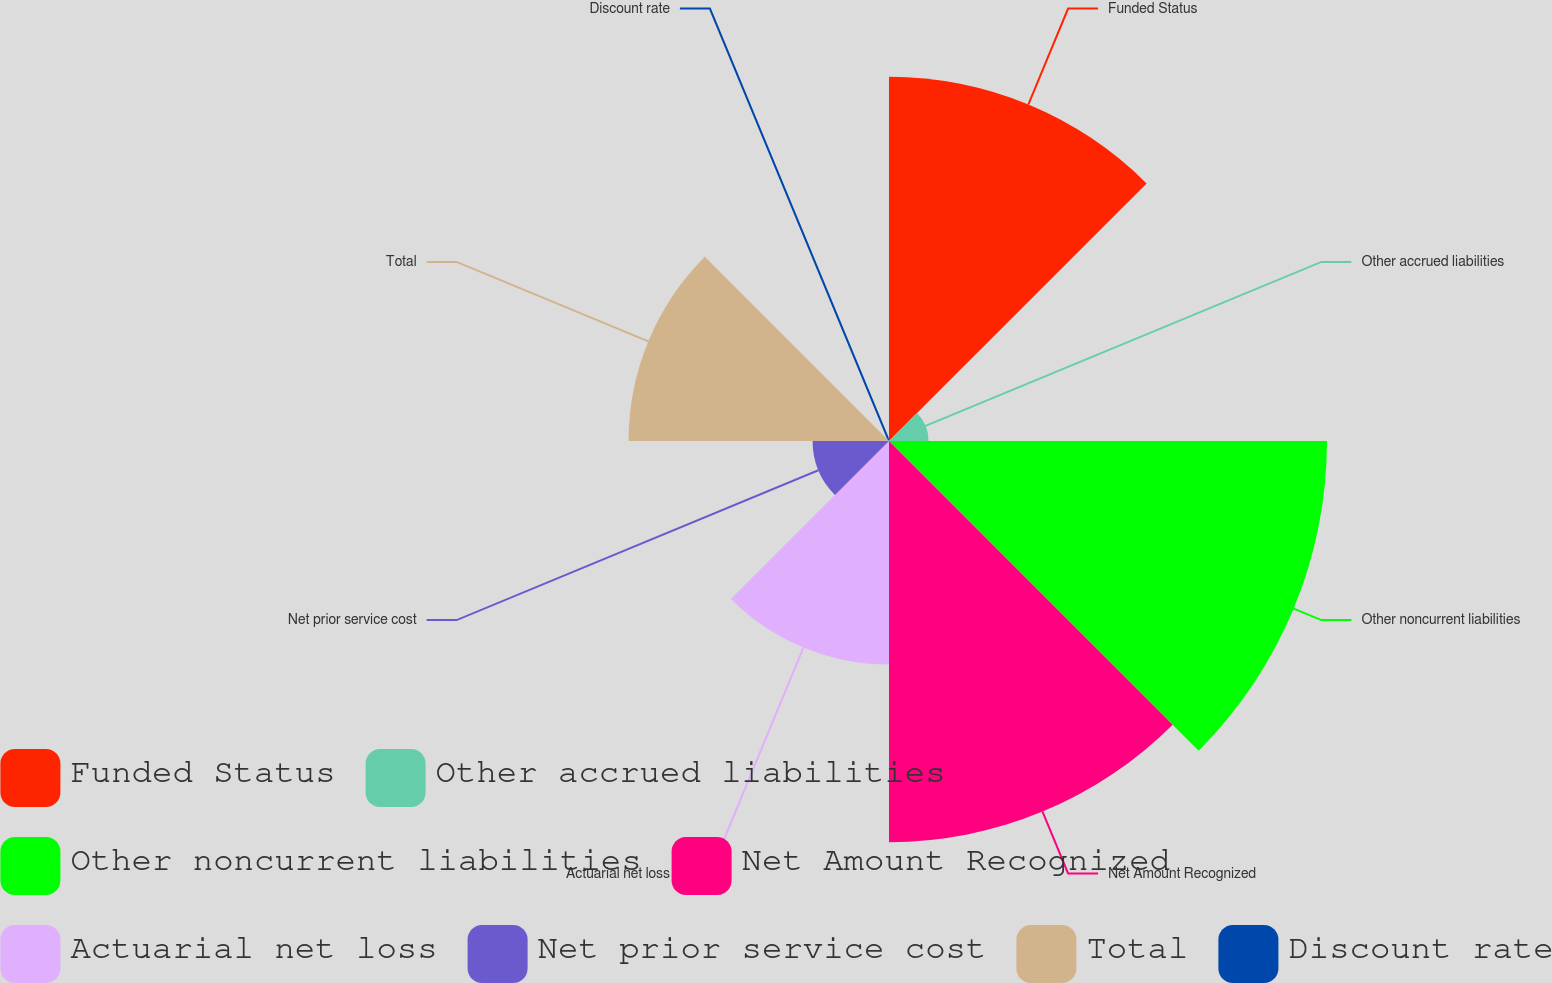<chart> <loc_0><loc_0><loc_500><loc_500><pie_chart><fcel>Funded Status<fcel>Other accrued liabilities<fcel>Other noncurrent liabilities<fcel>Net Amount Recognized<fcel>Actuarial net loss<fcel>Net prior service cost<fcel>Total<fcel>Discount rate<nl><fcel>20.17%<fcel>2.19%<fcel>24.25%<fcel>22.21%<fcel>12.38%<fcel>4.23%<fcel>14.42%<fcel>0.15%<nl></chart> 